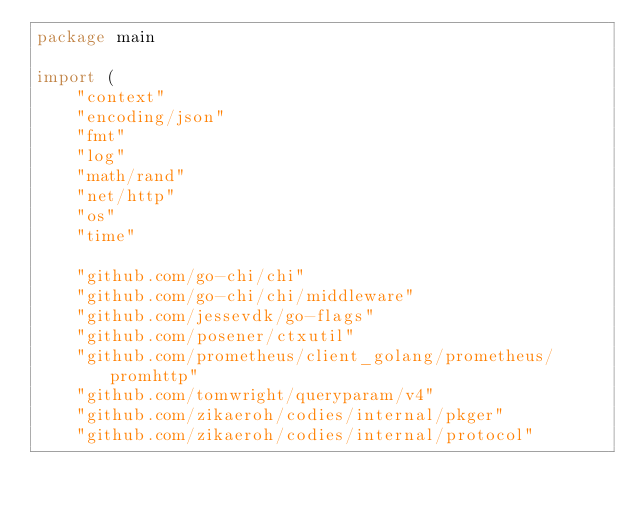<code> <loc_0><loc_0><loc_500><loc_500><_Go_>package main

import (
	"context"
	"encoding/json"
	"fmt"
	"log"
	"math/rand"
	"net/http"
	"os"
	"time"

	"github.com/go-chi/chi"
	"github.com/go-chi/chi/middleware"
	"github.com/jessevdk/go-flags"
	"github.com/posener/ctxutil"
	"github.com/prometheus/client_golang/prometheus/promhttp"
	"github.com/tomwright/queryparam/v4"
	"github.com/zikaeroh/codies/internal/pkger"
	"github.com/zikaeroh/codies/internal/protocol"</code> 